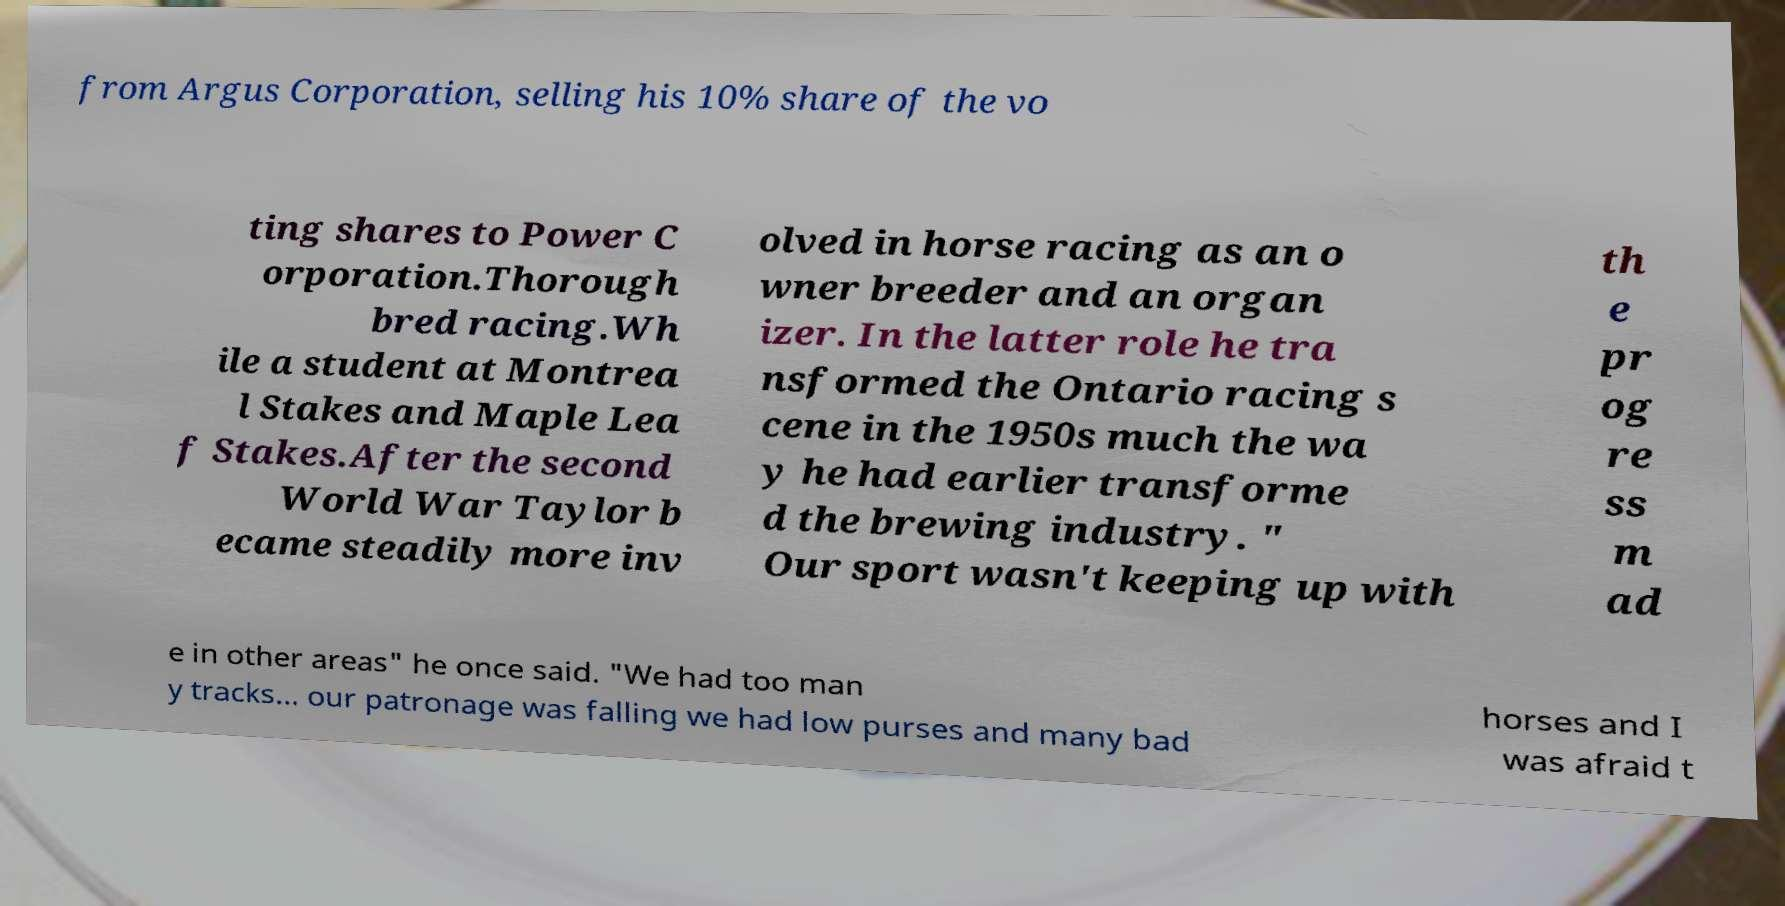Could you extract and type out the text from this image? from Argus Corporation, selling his 10% share of the vo ting shares to Power C orporation.Thorough bred racing.Wh ile a student at Montrea l Stakes and Maple Lea f Stakes.After the second World War Taylor b ecame steadily more inv olved in horse racing as an o wner breeder and an organ izer. In the latter role he tra nsformed the Ontario racing s cene in the 1950s much the wa y he had earlier transforme d the brewing industry. " Our sport wasn't keeping up with th e pr og re ss m ad e in other areas" he once said. "We had too man y tracks... our patronage was falling we had low purses and many bad horses and I was afraid t 